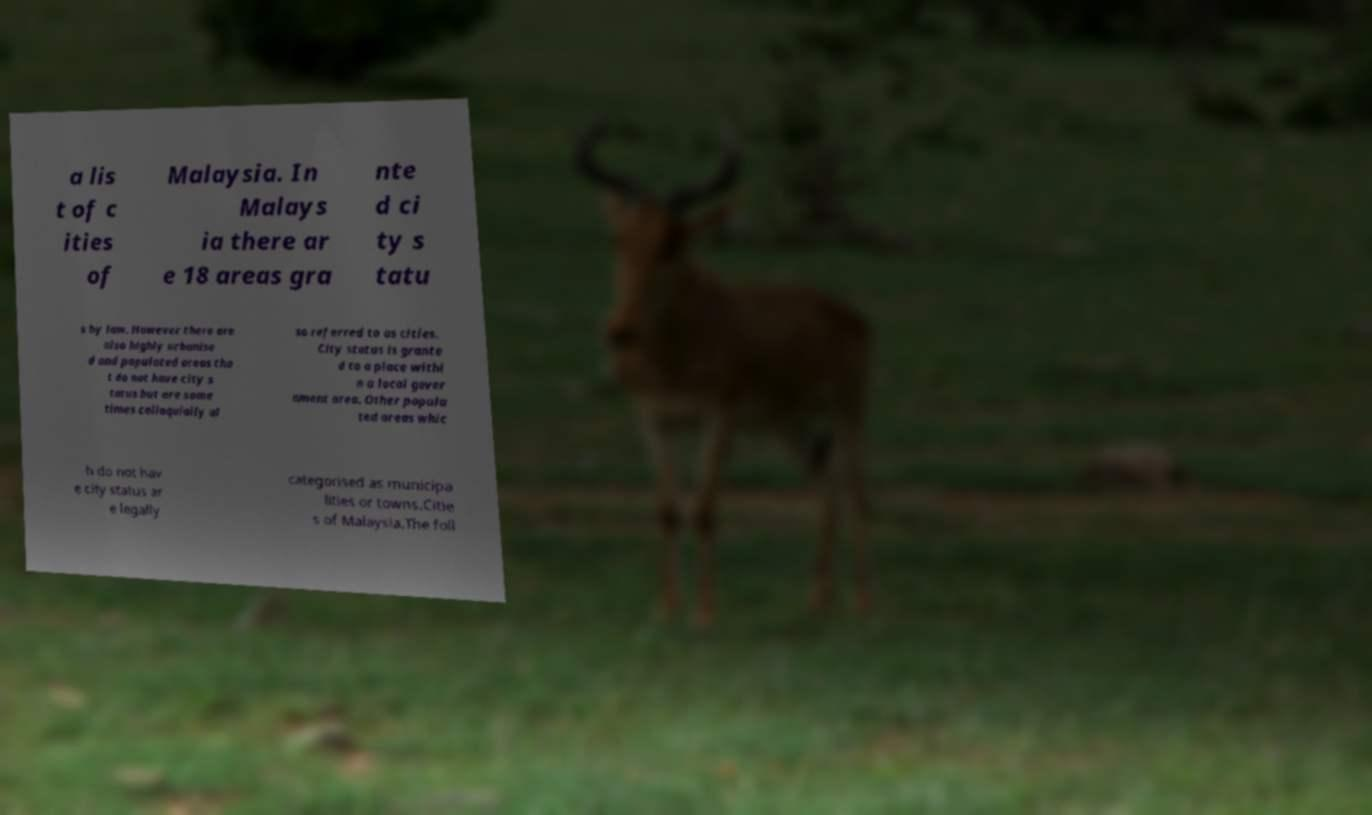Can you read and provide the text displayed in the image?This photo seems to have some interesting text. Can you extract and type it out for me? a lis t of c ities of Malaysia. In Malays ia there ar e 18 areas gra nte d ci ty s tatu s by law. However there are also highly urbanise d and populated areas tha t do not have city s tatus but are some times colloquially al so referred to as cities. City status is grante d to a place withi n a local gover nment area. Other popula ted areas whic h do not hav e city status ar e legally categorised as municipa lities or towns.Citie s of Malaysia.The foll 